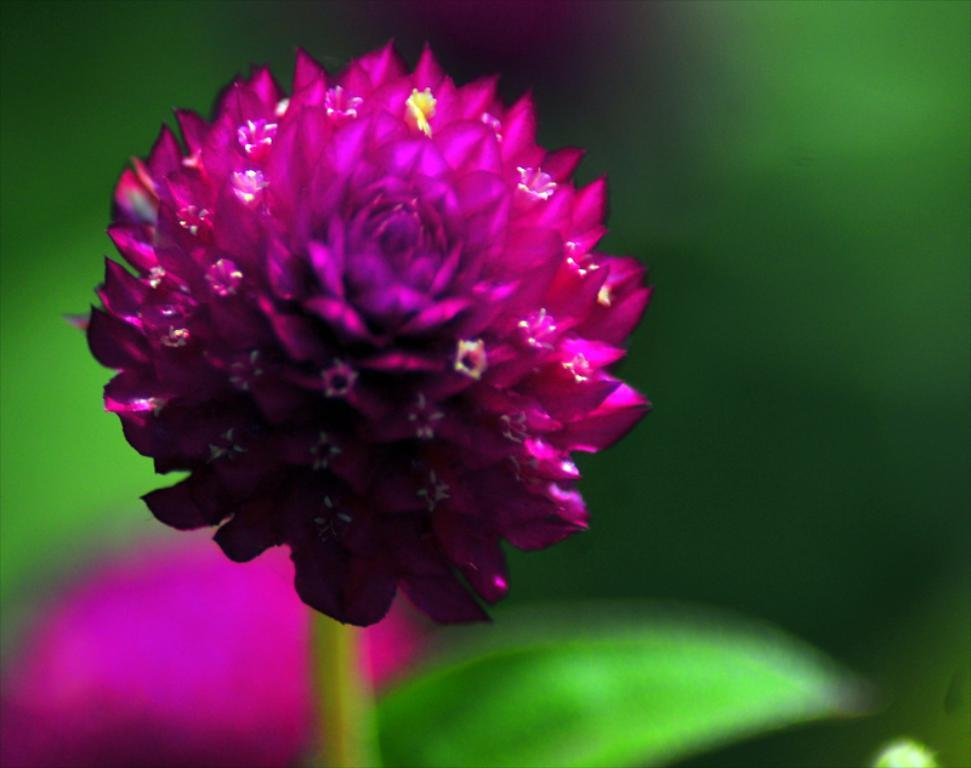What can be observed about the background of the image? The background of the image is blurred. What part of a plant can be seen in the image? There is a stem visible in the image. What part of a plant is also visible in the image? There is a leaf visible in the image. What type of plant is featured in the image? There is a flower in the image. What type of disease is affecting the flower in the image? There is no indication of any disease affecting the flower in the image. What type of produce is being harvested in the image? There is no produce being harvested in the image; it features a flower and parts of a plant. 